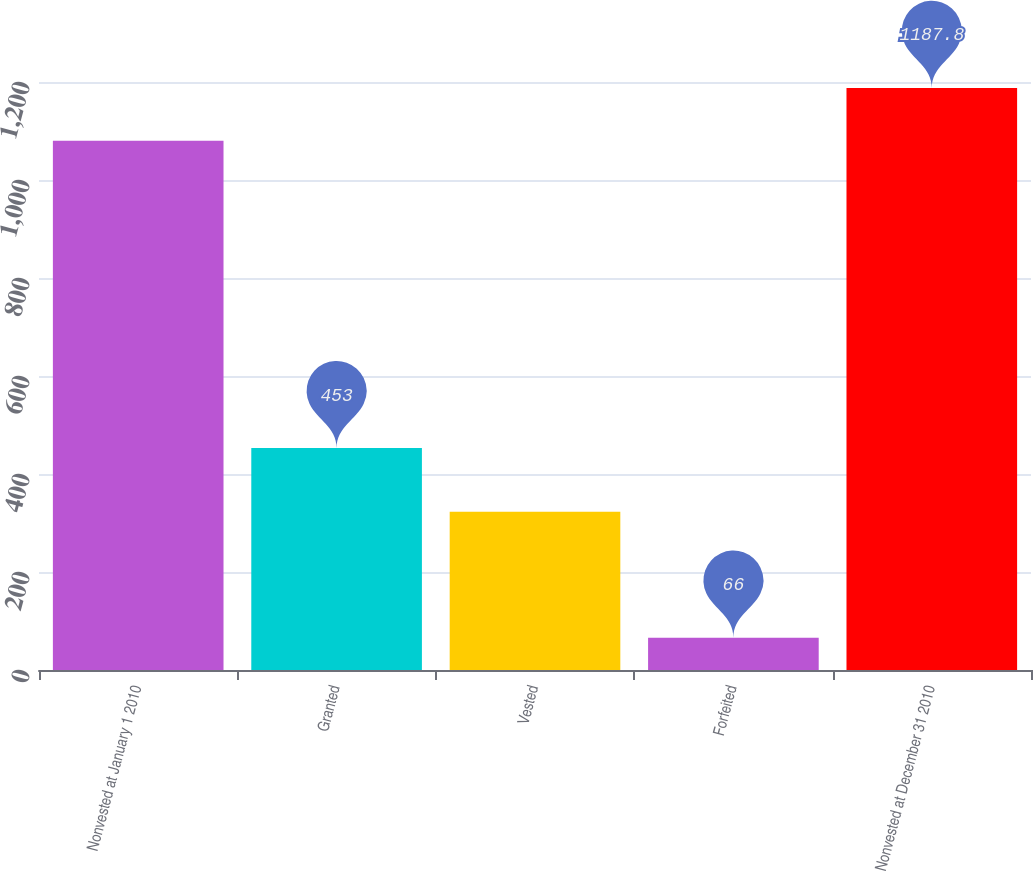Convert chart. <chart><loc_0><loc_0><loc_500><loc_500><bar_chart><fcel>Nonvested at January 1 2010<fcel>Granted<fcel>Vested<fcel>Forfeited<fcel>Nonvested at December 31 2010<nl><fcel>1080<fcel>453<fcel>323<fcel>66<fcel>1187.8<nl></chart> 